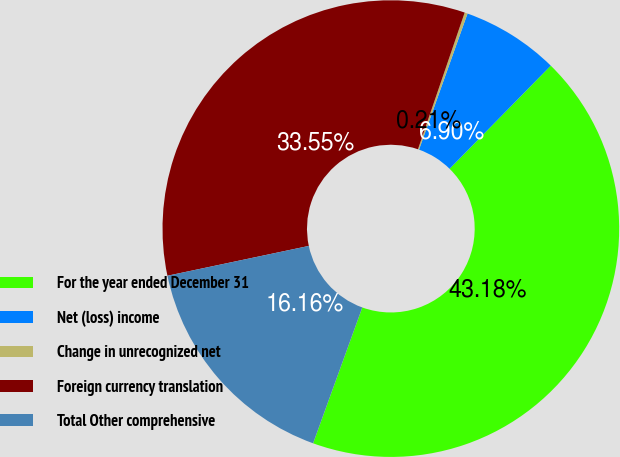Convert chart to OTSL. <chart><loc_0><loc_0><loc_500><loc_500><pie_chart><fcel>For the year ended December 31<fcel>Net (loss) income<fcel>Change in unrecognized net<fcel>Foreign currency translation<fcel>Total Other comprehensive<nl><fcel>43.18%<fcel>6.9%<fcel>0.21%<fcel>33.55%<fcel>16.16%<nl></chart> 